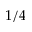<formula> <loc_0><loc_0><loc_500><loc_500>1 / 4</formula> 